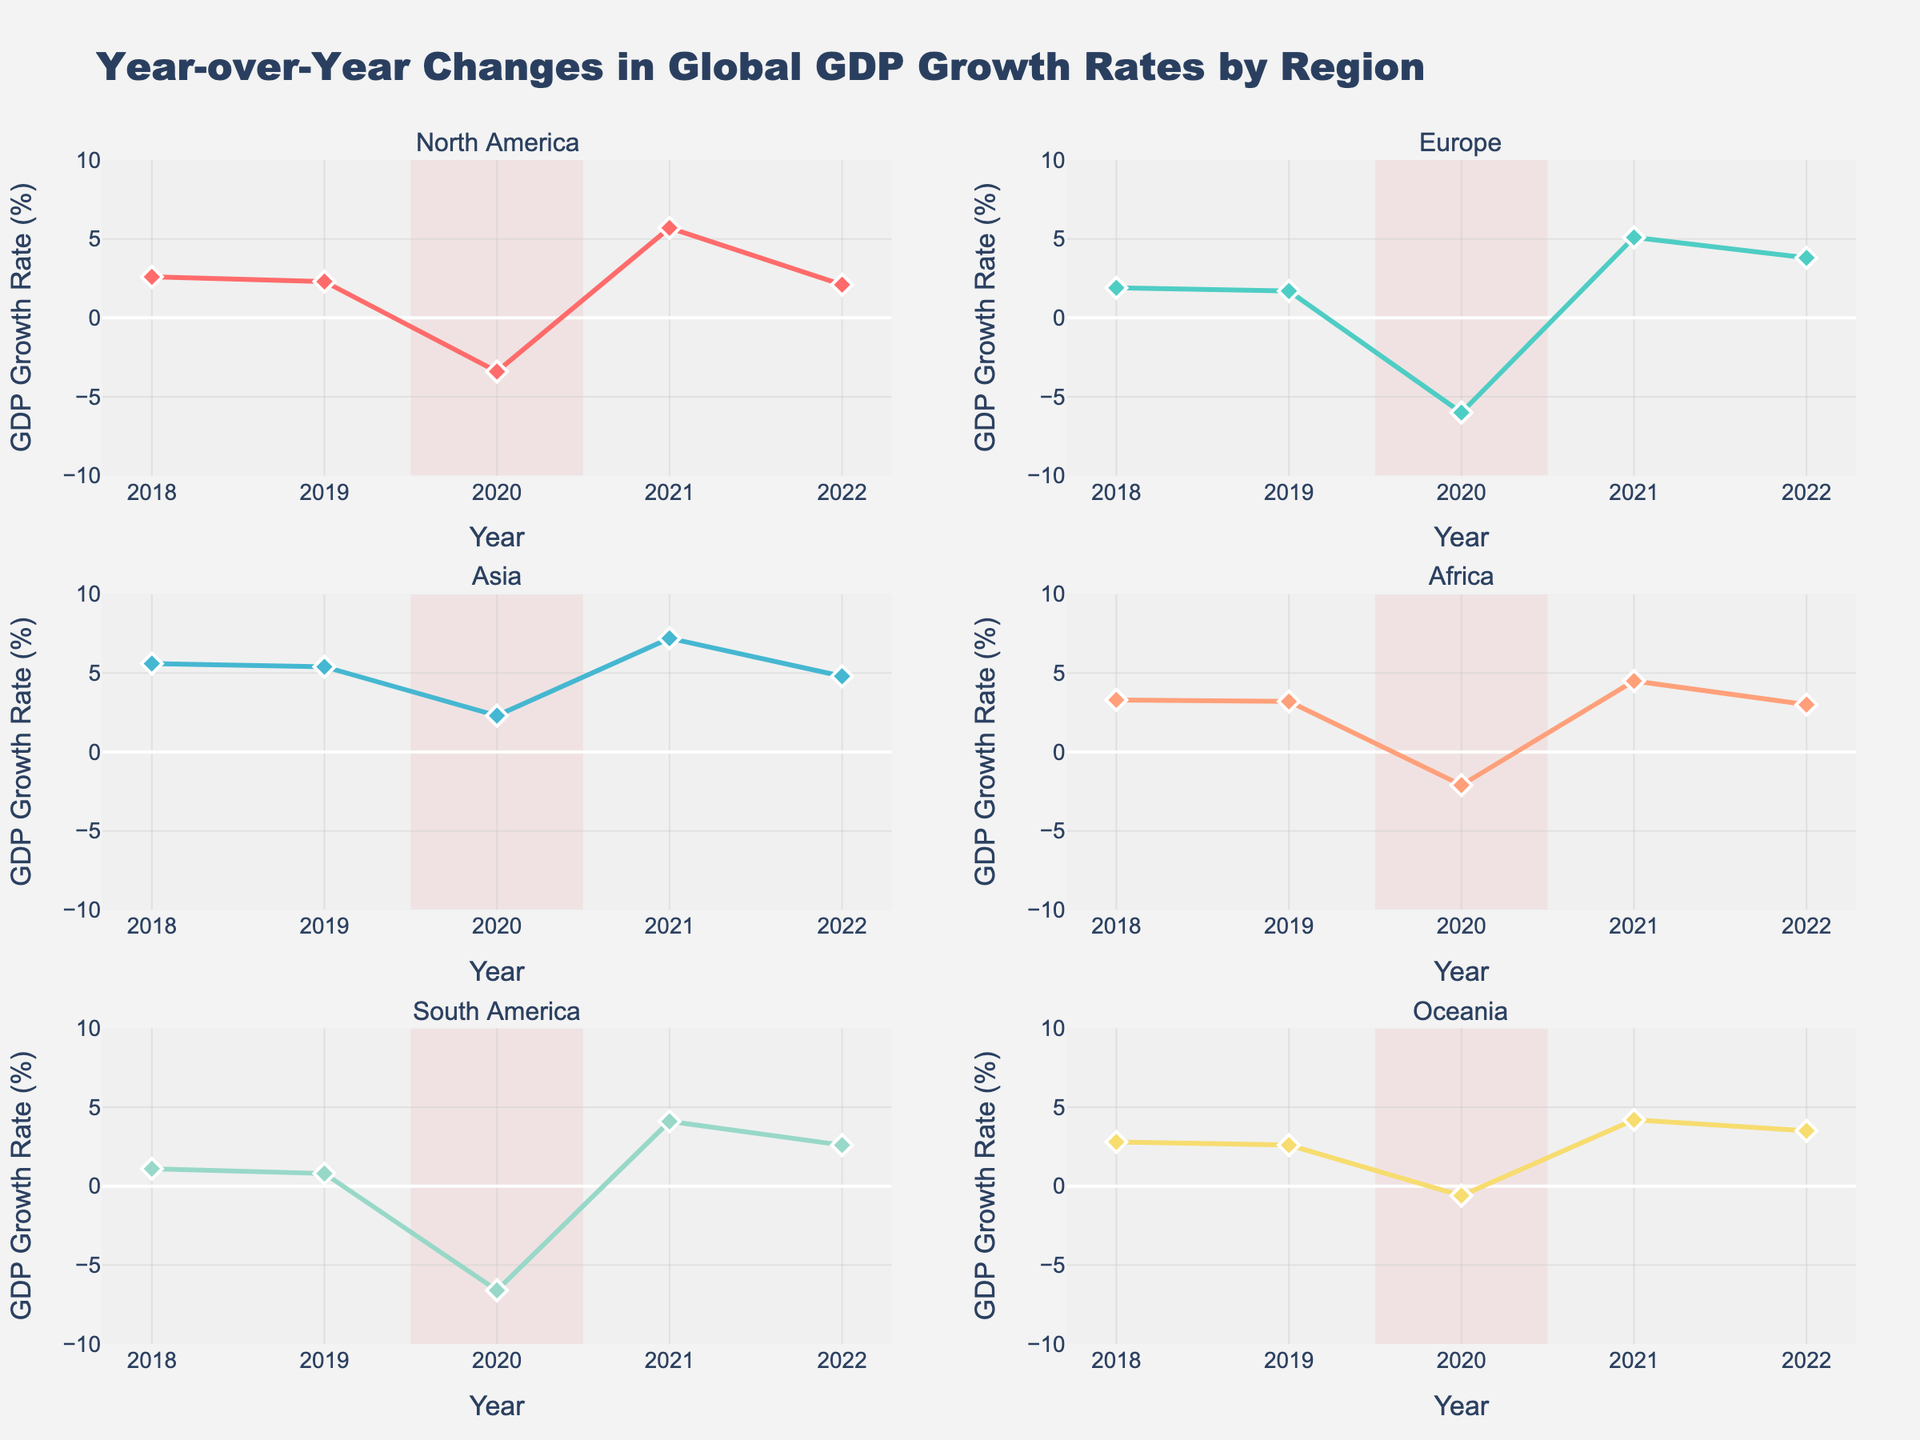What's the title of the figure? The title of the figure is usually located at the top of the chart. In this case, it reads "Year-over-Year Changes in Global GDP Growth Rates by Region".
Answer: Year-over-Year Changes in Global GDP Growth Rates by Region How did GDP growth in North America change from 2019 to 2020? In the North America subplot, the GDP growth rate in 2019 is 2.3% and drops to -3.4% in 2020. The change can be calculated by subtracting 2020's rate from 2019's rate: 2.3% - (-3.4%) = 2.3% + 3.4% = 5.7%.
Answer: It decreased by 5.7 percentage points Which region experienced the highest growth rate in 2021? Examining the peak value of GDP growth rates in 2021 for all regions shows that Asia has a growth rate of 7.2%, which is the highest among all regions.
Answer: Asia In which year did Europe experience its lowest GDP growth rate? Looking at the Europe subplot, the dip in 2020 to -6.0% represents Europe's lowest GDP growth rate for the years shown.
Answer: 2020 How many regions had negative GDP growth rates in 2020? In 2020, we look across subplots to identify regions with negative GDP growth rates. These regions are North America, Europe, Africa, and South America. Thus, 4 regions had negative growth rates.
Answer: 4 regions Compare the GDP growth rates of Africa and South America in 2022. Which one was higher? In 2022, Africa's GDP growth rate is 3.0%, and South America's is 2.6%. Comparing these values, Africa's rate is higher.
Answer: Africa What's the overall trend for GDP growth in Oceania from 2018 to 2022? By examining the Oceania subplot, we can see the trend of values: 2.8% (2018), 2.6% (2019), -0.6% (2020), 4.2% (2021), 3.5% (2022). After a drop in 2020, there is an overall increasing trend from 2020 to 2022.
Answer: Initially fluctuating with a decreasing trend, then increasing trend from 2020 onwards What is the color used to represent GDP growth rates for Europe? In the subplot for Europe, the plot line and markers are displayed in a greenish color from the color palette (#45B7D1).
Answer: Greenish color (approximately #45B7D1) What was the average GDP growth rate for Asia from 2018 to 2022? Asia's GDP growth rates over the years are 5.6%, 5.4%, 2.3%, 7.2%, and 4.8%. Summing these rates gives a total of 25.3%. The average is calculated as 25.3/5 = 5.06%.
Answer: 5.06% Which year was highlighted to indicate the COVID-19 period and what color is it? The COVID-19 period is highlighted between 2019.5 and 2020.5 using a translucent red rectangle on all subplots.
Answer: 2019-2020, translucent red 